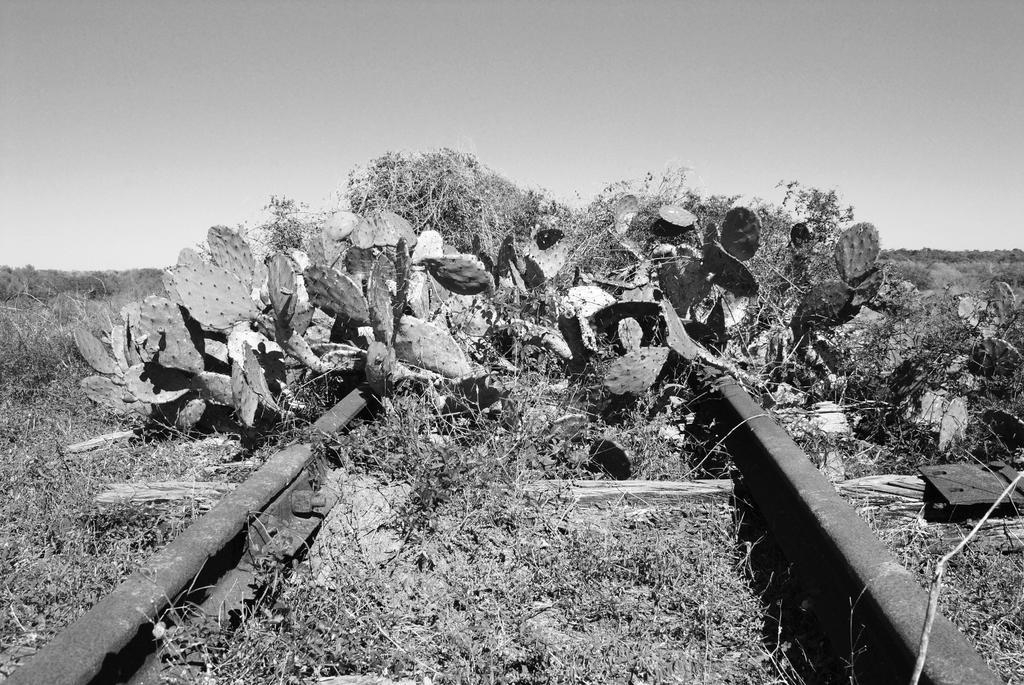Can you describe this image briefly? In this picture I can see the railway track. In the center I can see the plants, beside that I can see the dry grass. In the background I can see some trees. At the top I can see the sky. 